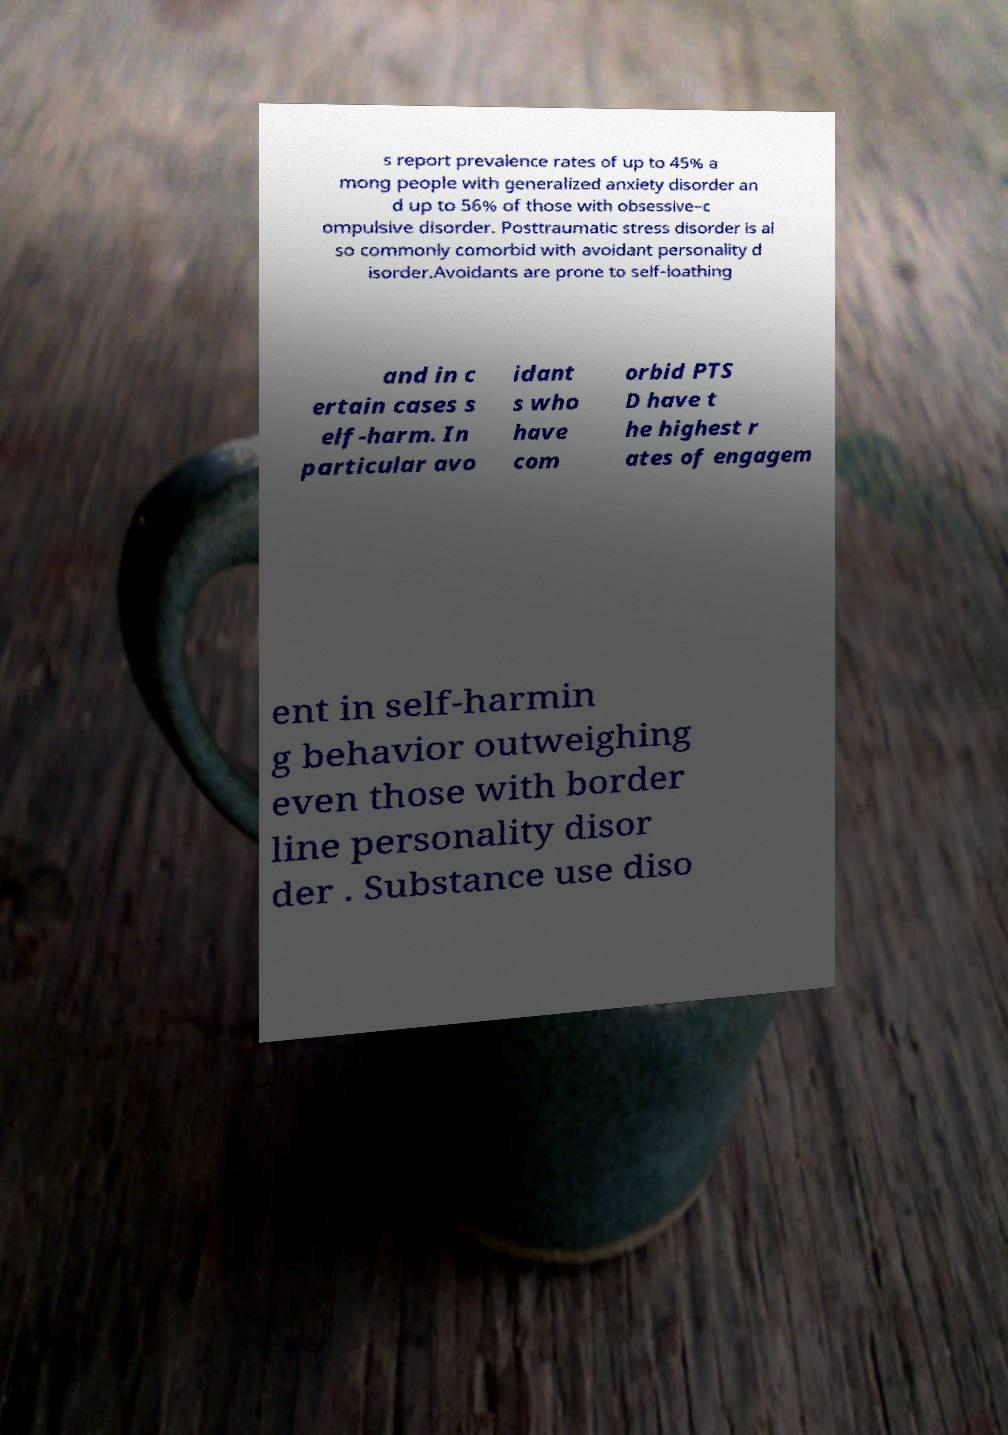Can you accurately transcribe the text from the provided image for me? s report prevalence rates of up to 45% a mong people with generalized anxiety disorder an d up to 56% of those with obsessive–c ompulsive disorder. Posttraumatic stress disorder is al so commonly comorbid with avoidant personality d isorder.Avoidants are prone to self-loathing and in c ertain cases s elf-harm. In particular avo idant s who have com orbid PTS D have t he highest r ates of engagem ent in self-harmin g behavior outweighing even those with border line personality disor der . Substance use diso 